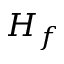Convert formula to latex. <formula><loc_0><loc_0><loc_500><loc_500>H _ { f }</formula> 